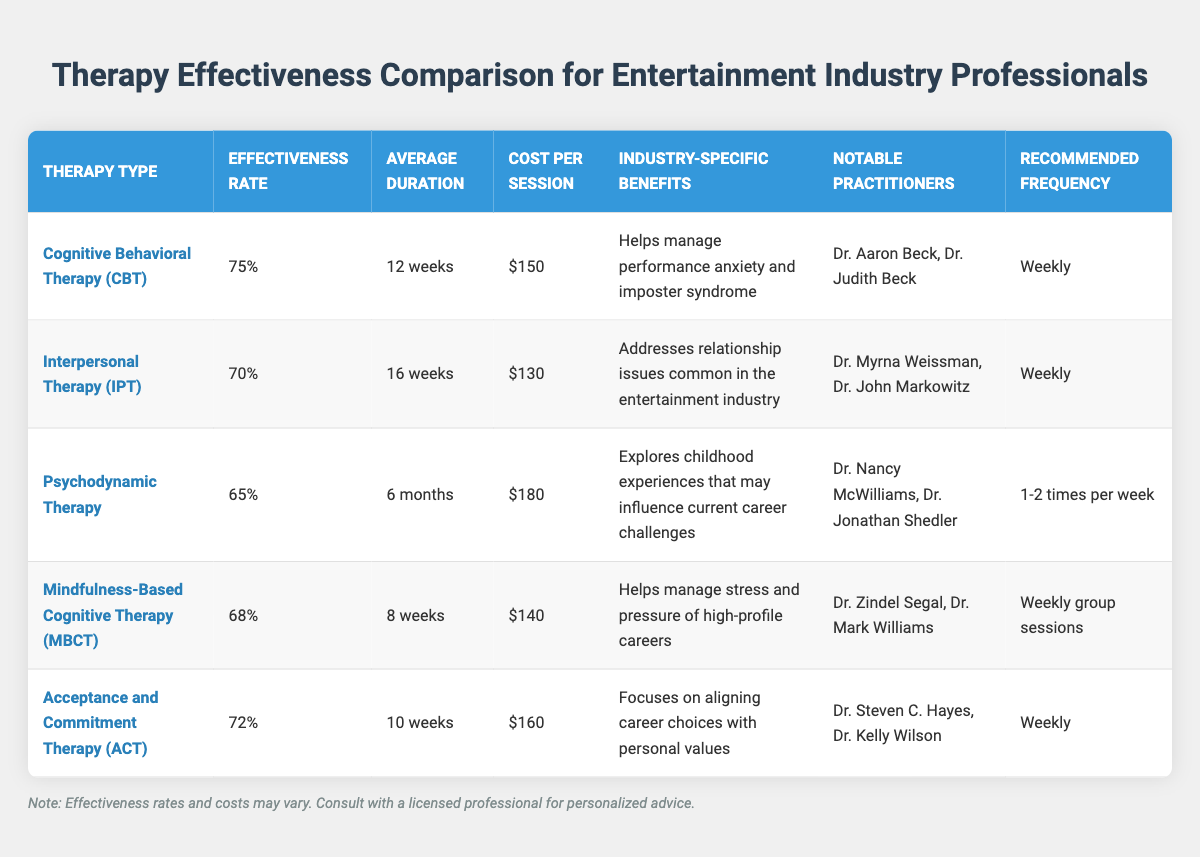What is the effectiveness rate of Cognitive Behavioral Therapy (CBT)? The table clearly shows the effectiveness rate of Cognitive Behavioral Therapy listed under the "Effectiveness Rate" column next to CBT, which is 75%.
Answer: 75% Which therapy has the lowest average treatment duration? By comparing the "Average Duration" column for each therapy, Mindfulness-Based Cognitive Therapy (MBCT) has the shortest duration of 8 weeks.
Answer: 8 weeks Does Interpersonal Therapy (IPT) address relationship issues in the entertainment industry? The "Industry-Specific Benefits" column for IPT explicitly states that it addresses relationship issues common in the entertainment industry, thus the answer is yes.
Answer: Yes What is the average cost per session of the therapies listed? First, we need to extract the cost per session values: 150, 130, 180, 140, and 160. Then, we sum them: (150 + 130 + 180 + 140 + 160) = 760. Next, we divide by the number of therapies (5) to obtain the average: 760 / 5 = 152.
Answer: 152 Is Acceptance and Commitment Therapy (ACT) more effective than Psychodynamic Therapy? The effectiveness rates from the table show ACT at 72% and Psychodynamic Therapy at 65%. Since 72% is greater than 65%, ACT is more effective than Psychodynamic Therapy.
Answer: Yes How much more does Psychodynamic Therapy cost per session compared to Interpersonal Therapy (IPT)? The costs per session from the table show Psychodynamic Therapy costs $180 and IPT costs $130. We find the difference by calculating: 180 - 130 = 50.
Answer: 50 What is the relationship between the effectiveness rate and average treatment duration for Mindfulness-Based Cognitive Therapy (MBCT)? Looking at the table, MBCT has an effectiveness rate of 68% with an average treatment duration of 8 weeks. By discussing the context, we note that a relatively shorter duration might contribute to a moderate effectiveness rate compared to longer treatments, like Psychodynamic Therapy.
Answer: 68% effectiveness with 8 weeks duration Which therapy has the highest cost per session and what is its effectiveness rate? From the table, Psychodynamic Therapy has the highest cost per session at $180 and its effectiveness rate listed is 65%.
Answer: $180 cost and 65% effectiveness 